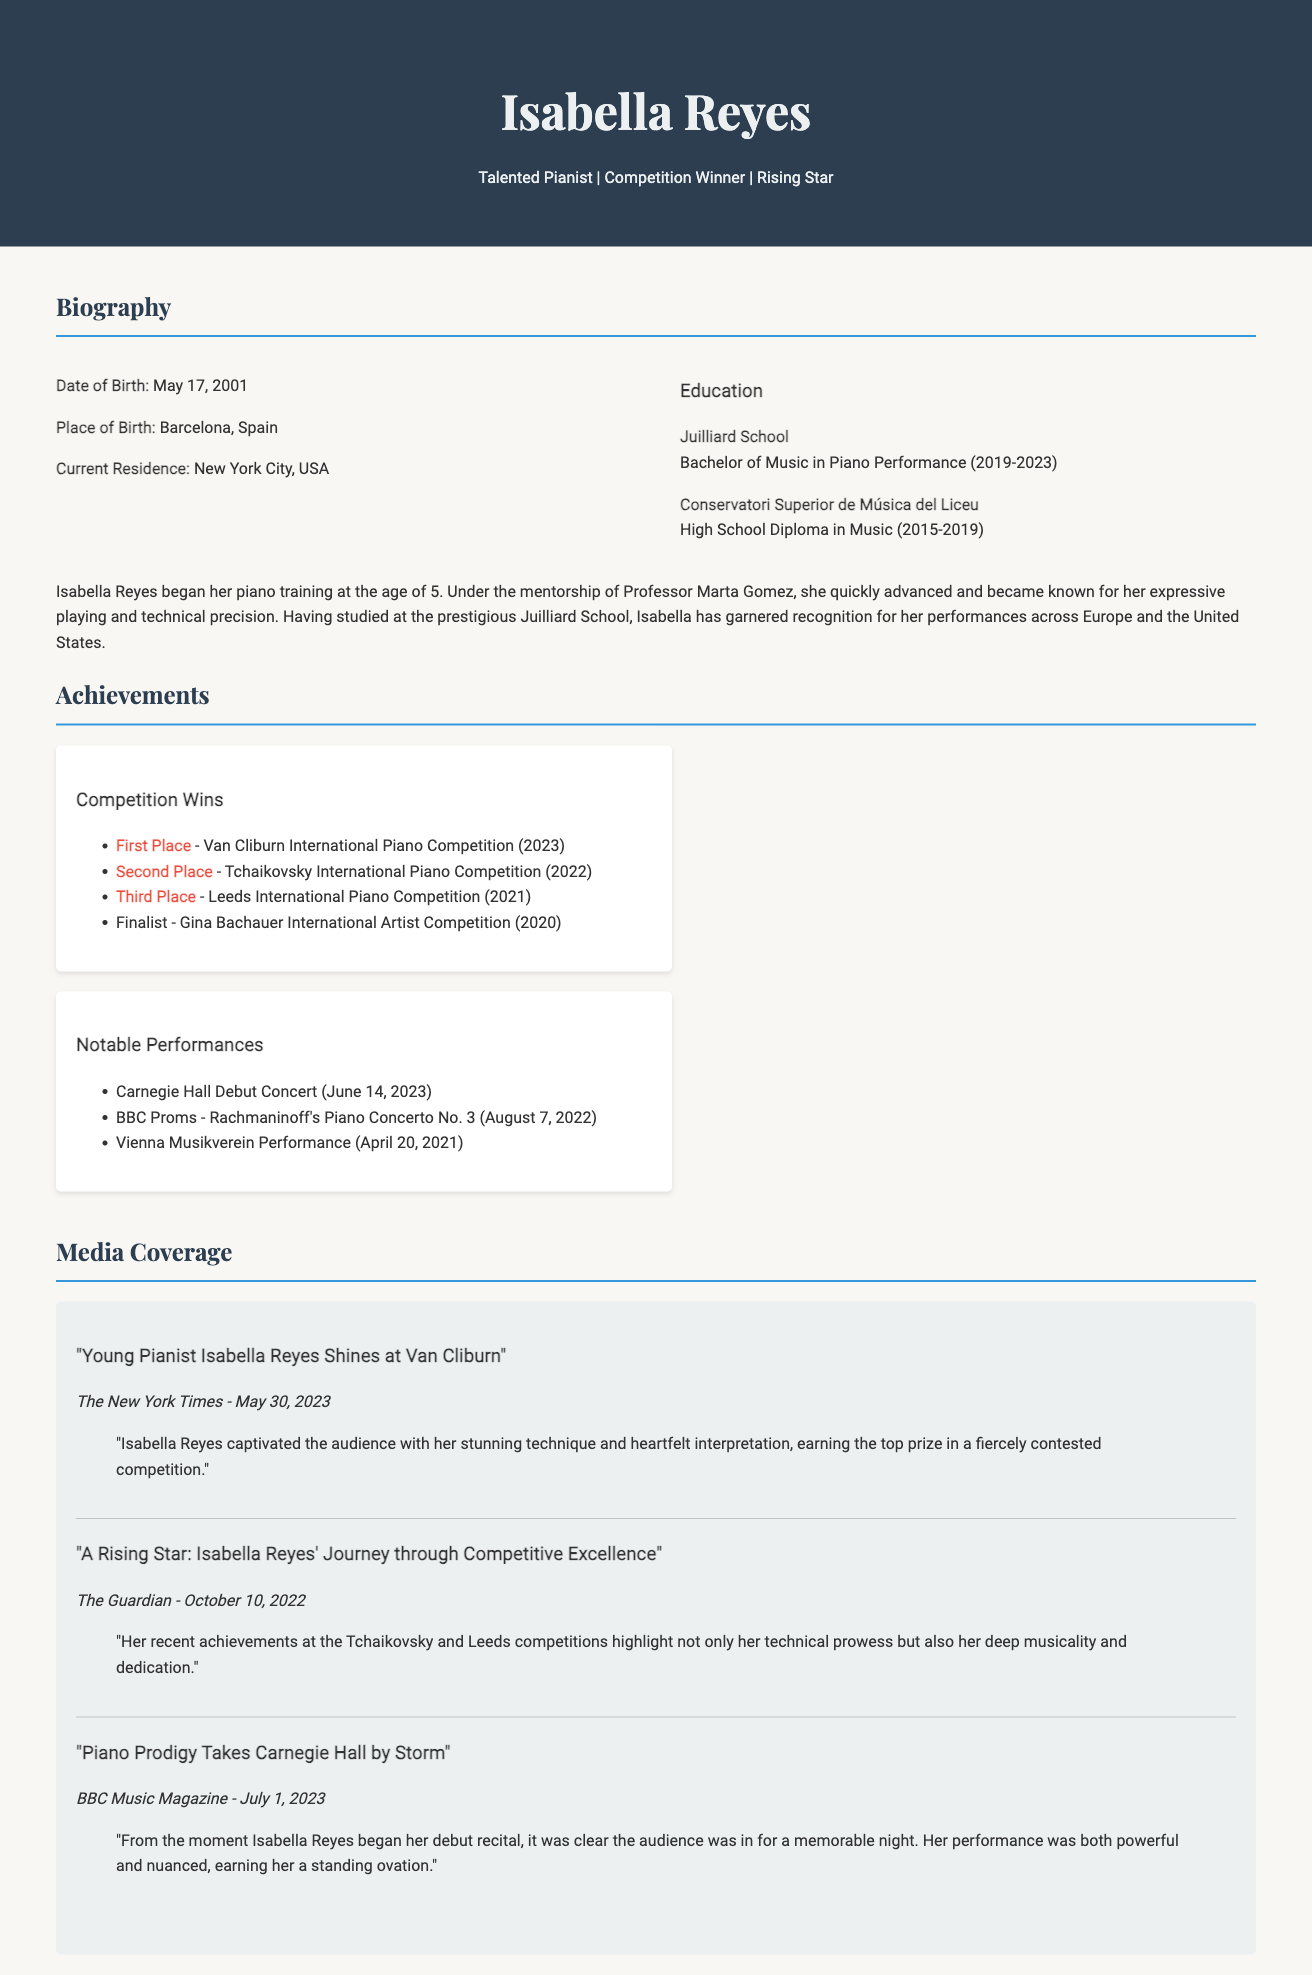what is Isabella Reyes' date of birth? The document states Isabella Reyes was born on May 17, 2001.
Answer: May 17, 2001 where did Isabella grow up? The document mentions that Isabella was born in Barcelona, Spain.
Answer: Barcelona, Spain what is Isabella's current residence? The document indicates that Isabella currently lives in New York City, USA.
Answer: New York City, USA which competition did Isabella win in 2023? According to the document, Isabella won the Van Cliburn International Piano Competition in 2023.
Answer: Van Cliburn International Piano Competition how many places did Isabella achieve in the Tchaikovsky International Piano Competition? The document states that Isabella achieved second place in the Tchaikovsky International Piano Competition.
Answer: Second Place what notable performance did Isabella have on June 14, 2023? The document lists Isabella’s Carnegie Hall debut concert on June 14, 2023, as a notable performance.
Answer: Carnegie Hall Debut Concert who wrote about Isabella’s performance at the Van Cliburn? The document cites The New York Times as the publication that wrote about her performance.
Answer: The New York Times which prestigious school did Isabella attend for her music education? The document details that Isabella attended the Juilliard School for her Bachelor's degree in Piano Performance.
Answer: Juilliard School what is the main professional title given to Isabella in the document? The document refers to Isabella as a "Talented Pianist."
Answer: Talented Pianist 